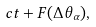<formula> <loc_0><loc_0><loc_500><loc_500>c t + F ( \Delta \theta _ { \alpha } ) ,</formula> 